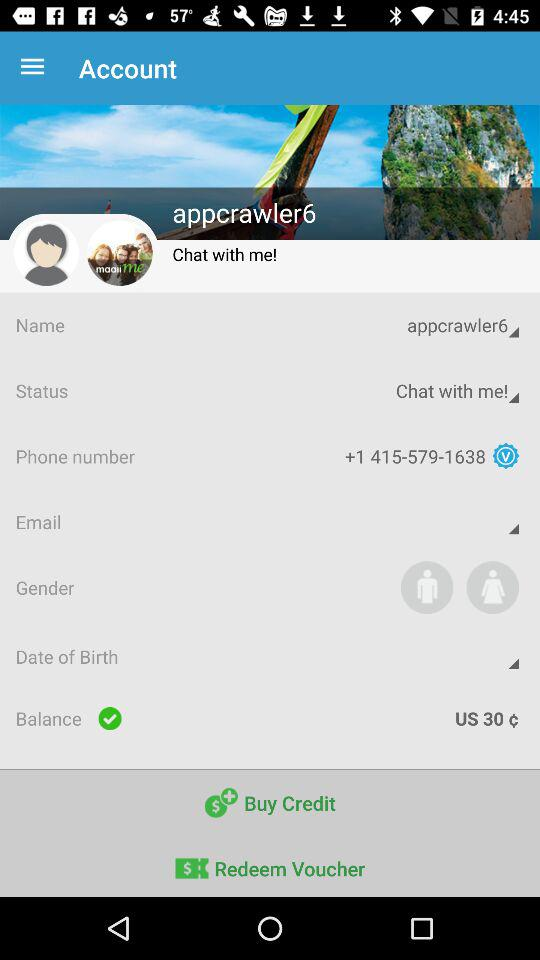How much money does the user have in their account?
Answer the question using a single word or phrase. US 30 $ 